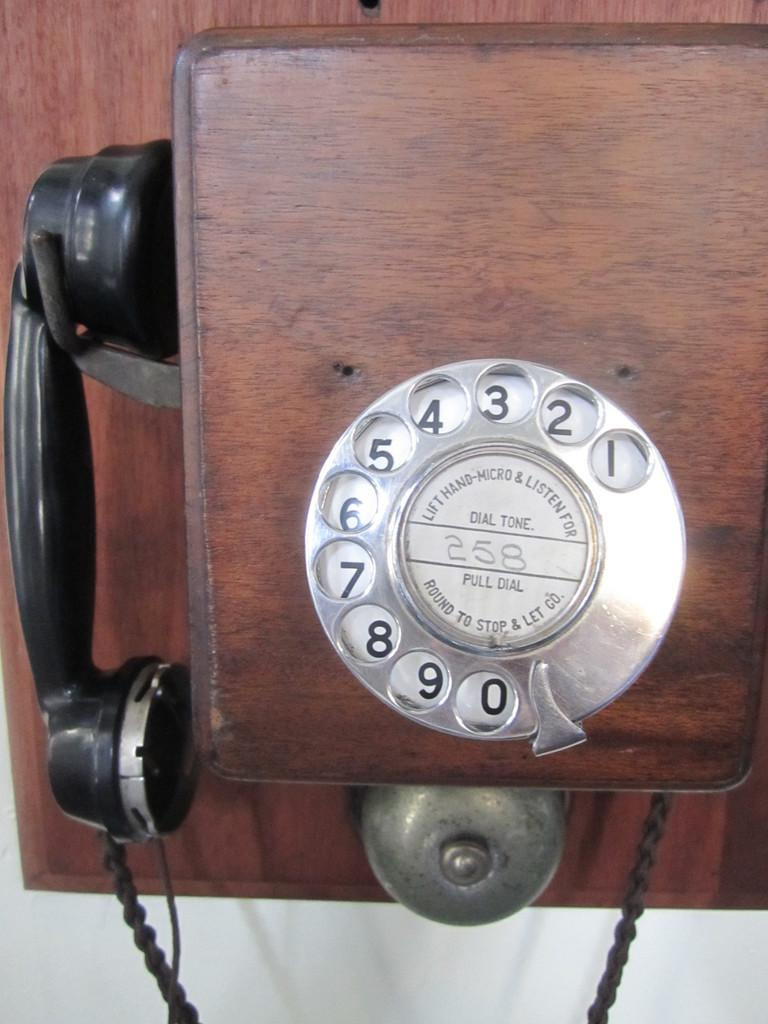<image>
Write a terse but informative summary of the picture. a telephone with 258 written in the middle of it 